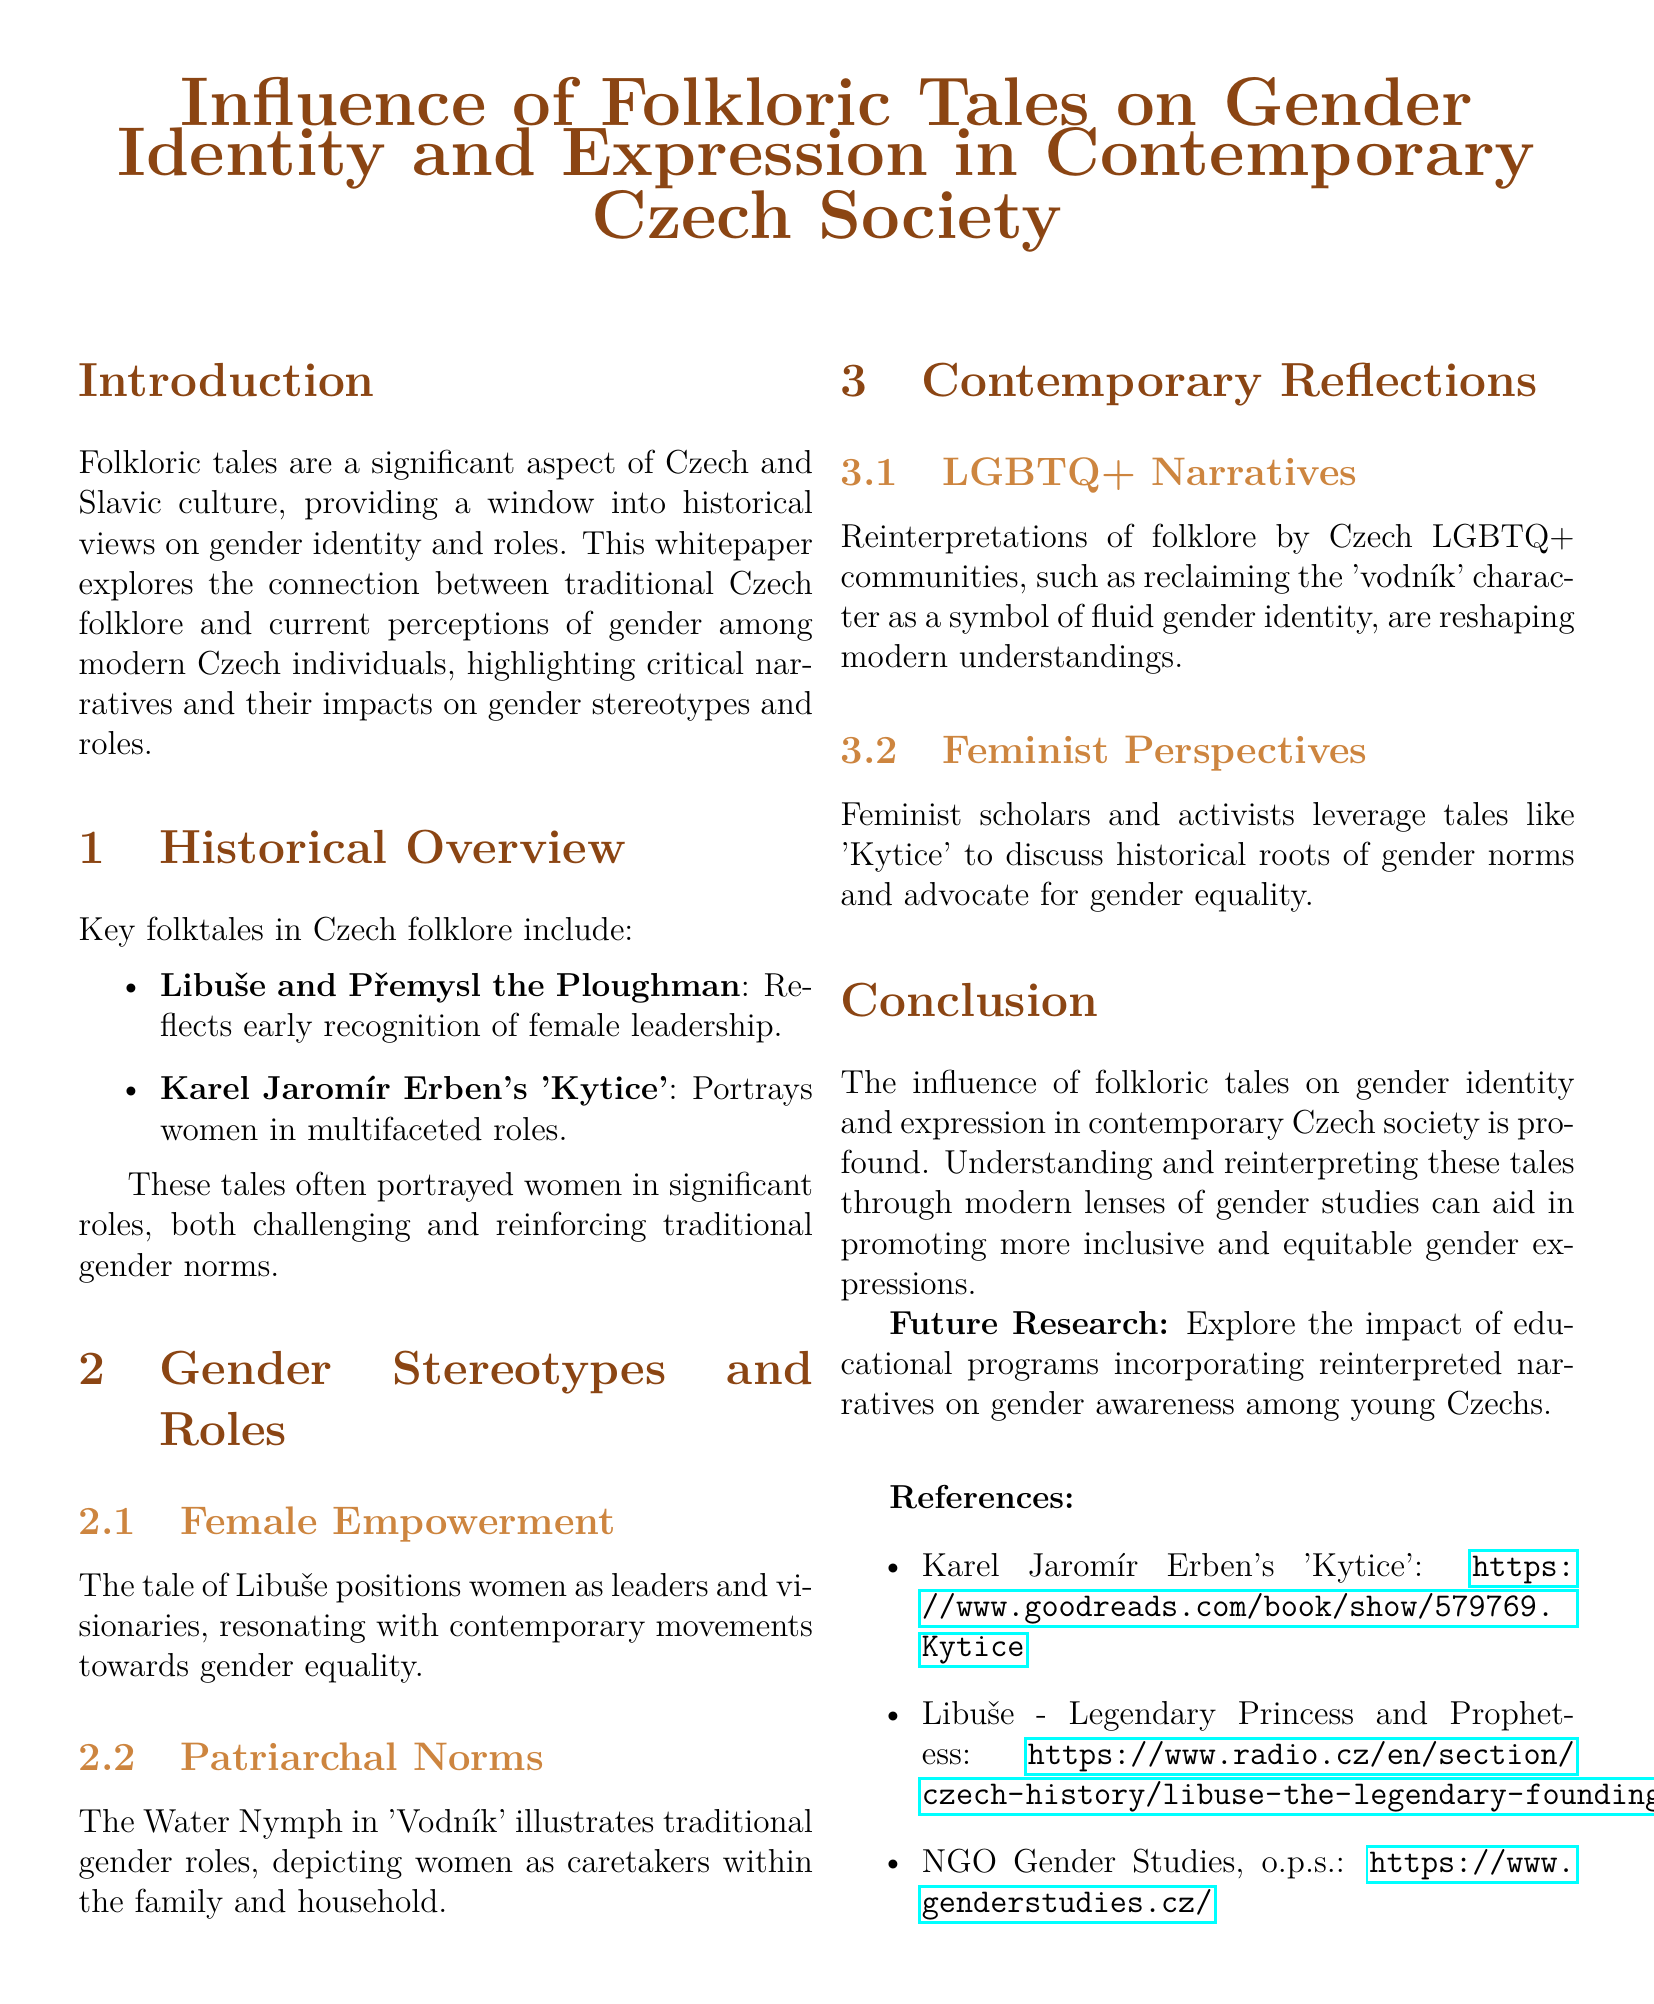What is the title of the whitepaper? The title of the whitepaper is mentioned prominently at the top of the document.
Answer: Influence of Folkloric Tales on Gender Identity and Expression in Contemporary Czech Society Who is the legendary princess mentioned in the document? The document references a significant figure in Czech folklore who represents female leadership.
Answer: Libuše What does the tale of Libuše reflect? The document describes the themes present in Libuše's story, particularly regarding women's roles.
Answer: Female leadership Which work by Karel Jaromír Erben is referenced in the document? The document lists a famous collection of poems that illustrates women in various roles.
Answer: Kytice What is a key theme in the 'Vodník' tale? The document discusses traditional gender roles as depicted in this folklore character.
Answer: Caretakers within the family What type of narratives are being reinterpreted by the LGBTQ+ communities? The document highlights a specific aspect of folklore that modern groups are reclaiming.
Answer: Folklore narratives What is the future research recommendation presented in the conclusion? The document suggests a specific area of study related to education and gender awareness.
Answer: Impact of educational programs What is the role of feminist scholars regarding folklore as mentioned in the document? The document outlines how feminist perspectives utilize folklore for social advocacy.
Answer: Advocate for gender equality How many folktales are specifically mentioned in the Historical Overview section? The document lists the folktales included in this section, indicating their significance.
Answer: Two 